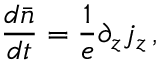Convert formula to latex. <formula><loc_0><loc_0><loc_500><loc_500>\frac { d \bar { n } } { d t } = \frac { 1 } { e } \partial _ { z } j _ { z } \, ,</formula> 